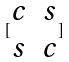Convert formula to latex. <formula><loc_0><loc_0><loc_500><loc_500>[ \begin{matrix} c & s \\ s & c \end{matrix} ]</formula> 